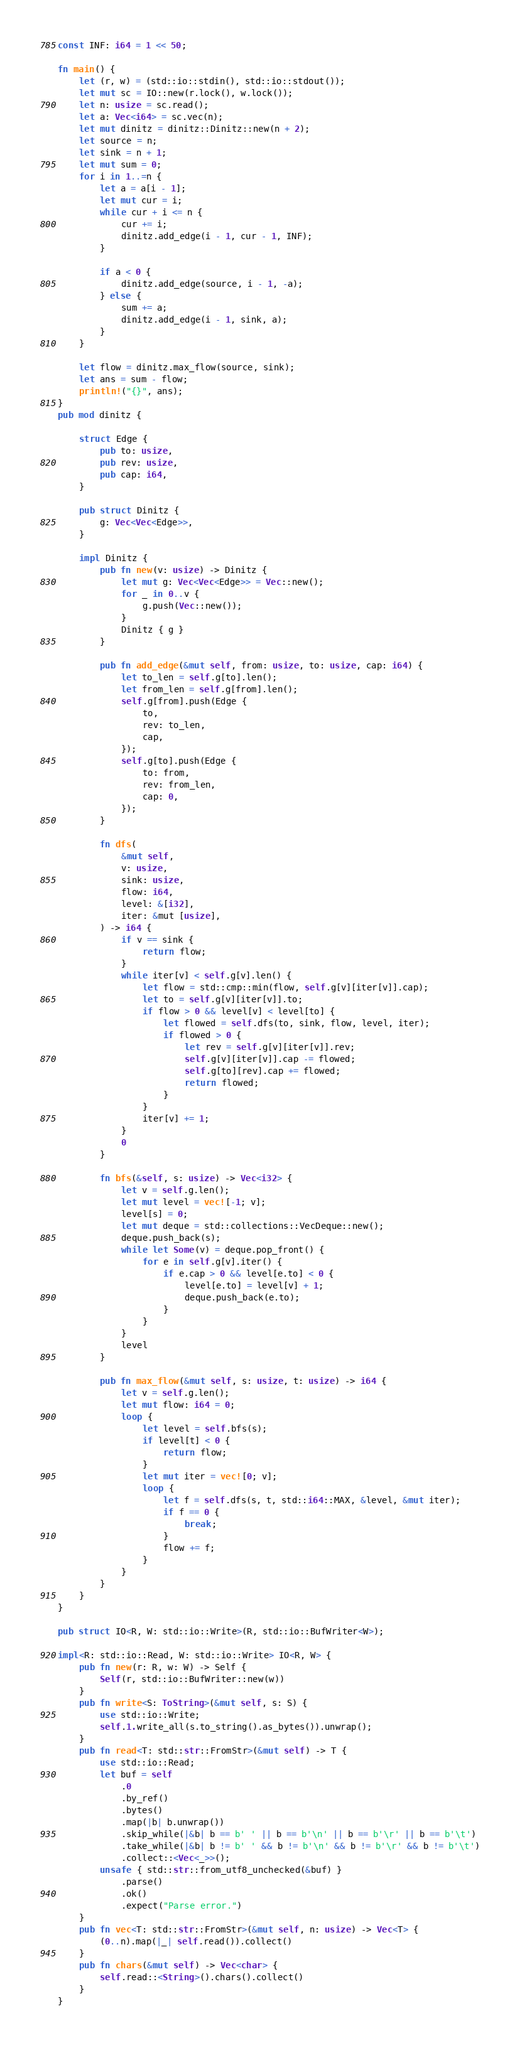Convert code to text. <code><loc_0><loc_0><loc_500><loc_500><_Rust_>const INF: i64 = 1 << 50;

fn main() {
    let (r, w) = (std::io::stdin(), std::io::stdout());
    let mut sc = IO::new(r.lock(), w.lock());
    let n: usize = sc.read();
    let a: Vec<i64> = sc.vec(n);
    let mut dinitz = dinitz::Dinitz::new(n + 2);
    let source = n;
    let sink = n + 1;
    let mut sum = 0;
    for i in 1..=n {
        let a = a[i - 1];
        let mut cur = i;
        while cur + i <= n {
            cur += i;
            dinitz.add_edge(i - 1, cur - 1, INF);
        }

        if a < 0 {
            dinitz.add_edge(source, i - 1, -a);
        } else {
            sum += a;
            dinitz.add_edge(i - 1, sink, a);
        }
    }

    let flow = dinitz.max_flow(source, sink);
    let ans = sum - flow;
    println!("{}", ans);
}
pub mod dinitz {

    struct Edge {
        pub to: usize,
        pub rev: usize,
        pub cap: i64,
    }

    pub struct Dinitz {
        g: Vec<Vec<Edge>>,
    }

    impl Dinitz {
        pub fn new(v: usize) -> Dinitz {
            let mut g: Vec<Vec<Edge>> = Vec::new();
            for _ in 0..v {
                g.push(Vec::new());
            }
            Dinitz { g }
        }

        pub fn add_edge(&mut self, from: usize, to: usize, cap: i64) {
            let to_len = self.g[to].len();
            let from_len = self.g[from].len();
            self.g[from].push(Edge {
                to,
                rev: to_len,
                cap,
            });
            self.g[to].push(Edge {
                to: from,
                rev: from_len,
                cap: 0,
            });
        }

        fn dfs(
            &mut self,
            v: usize,
            sink: usize,
            flow: i64,
            level: &[i32],
            iter: &mut [usize],
        ) -> i64 {
            if v == sink {
                return flow;
            }
            while iter[v] < self.g[v].len() {
                let flow = std::cmp::min(flow, self.g[v][iter[v]].cap);
                let to = self.g[v][iter[v]].to;
                if flow > 0 && level[v] < level[to] {
                    let flowed = self.dfs(to, sink, flow, level, iter);
                    if flowed > 0 {
                        let rev = self.g[v][iter[v]].rev;
                        self.g[v][iter[v]].cap -= flowed;
                        self.g[to][rev].cap += flowed;
                        return flowed;
                    }
                }
                iter[v] += 1;
            }
            0
        }

        fn bfs(&self, s: usize) -> Vec<i32> {
            let v = self.g.len();
            let mut level = vec![-1; v];
            level[s] = 0;
            let mut deque = std::collections::VecDeque::new();
            deque.push_back(s);
            while let Some(v) = deque.pop_front() {
                for e in self.g[v].iter() {
                    if e.cap > 0 && level[e.to] < 0 {
                        level[e.to] = level[v] + 1;
                        deque.push_back(e.to);
                    }
                }
            }
            level
        }

        pub fn max_flow(&mut self, s: usize, t: usize) -> i64 {
            let v = self.g.len();
            let mut flow: i64 = 0;
            loop {
                let level = self.bfs(s);
                if level[t] < 0 {
                    return flow;
                }
                let mut iter = vec![0; v];
                loop {
                    let f = self.dfs(s, t, std::i64::MAX, &level, &mut iter);
                    if f == 0 {
                        break;
                    }
                    flow += f;
                }
            }
        }
    }
}

pub struct IO<R, W: std::io::Write>(R, std::io::BufWriter<W>);

impl<R: std::io::Read, W: std::io::Write> IO<R, W> {
    pub fn new(r: R, w: W) -> Self {
        Self(r, std::io::BufWriter::new(w))
    }
    pub fn write<S: ToString>(&mut self, s: S) {
        use std::io::Write;
        self.1.write_all(s.to_string().as_bytes()).unwrap();
    }
    pub fn read<T: std::str::FromStr>(&mut self) -> T {
        use std::io::Read;
        let buf = self
            .0
            .by_ref()
            .bytes()
            .map(|b| b.unwrap())
            .skip_while(|&b| b == b' ' || b == b'\n' || b == b'\r' || b == b'\t')
            .take_while(|&b| b != b' ' && b != b'\n' && b != b'\r' && b != b'\t')
            .collect::<Vec<_>>();
        unsafe { std::str::from_utf8_unchecked(&buf) }
            .parse()
            .ok()
            .expect("Parse error.")
    }
    pub fn vec<T: std::str::FromStr>(&mut self, n: usize) -> Vec<T> {
        (0..n).map(|_| self.read()).collect()
    }
    pub fn chars(&mut self) -> Vec<char> {
        self.read::<String>().chars().collect()
    }
}
</code> 